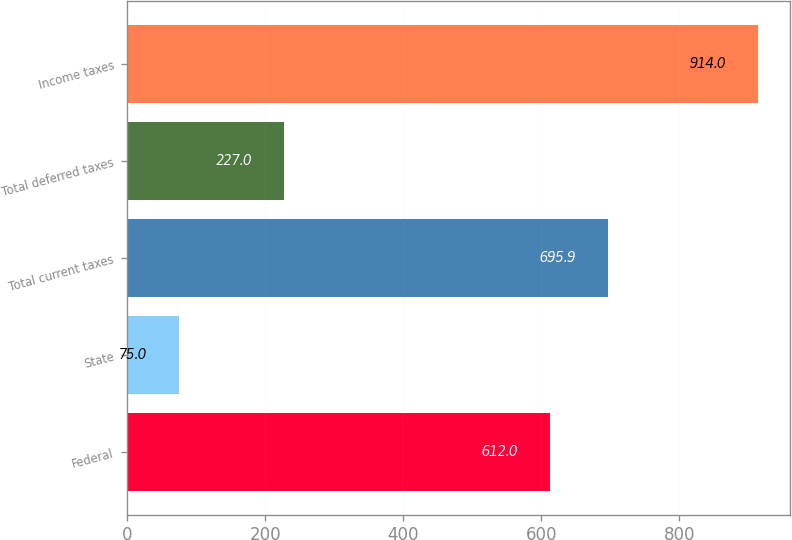Convert chart to OTSL. <chart><loc_0><loc_0><loc_500><loc_500><bar_chart><fcel>Federal<fcel>State<fcel>Total current taxes<fcel>Total deferred taxes<fcel>Income taxes<nl><fcel>612<fcel>75<fcel>695.9<fcel>227<fcel>914<nl></chart> 